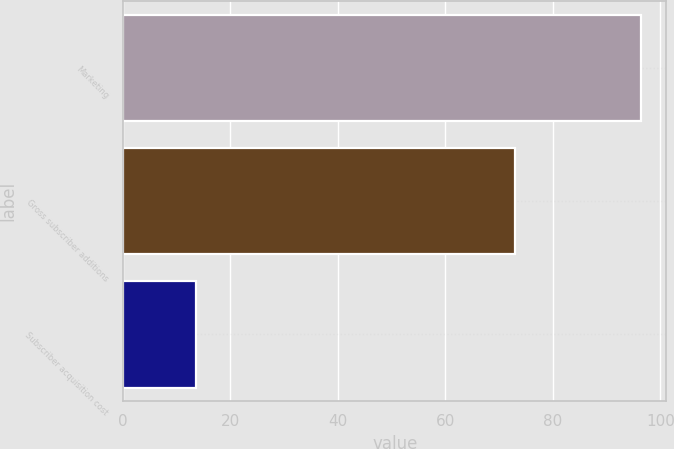Convert chart to OTSL. <chart><loc_0><loc_0><loc_500><loc_500><bar_chart><fcel>Marketing<fcel>Gross subscriber additions<fcel>Subscriber acquisition cost<nl><fcel>96.3<fcel>72.9<fcel>13.5<nl></chart> 